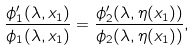Convert formula to latex. <formula><loc_0><loc_0><loc_500><loc_500>\frac { \phi _ { 1 } ^ { \prime } ( \lambda , x _ { 1 } ) } { \phi _ { 1 } ( \lambda , x _ { 1 } ) } = \frac { \phi _ { 2 } ^ { \prime } ( \lambda , \eta ( x _ { 1 } ) ) } { \phi _ { 2 } ( \lambda , \eta ( x _ { 1 } ) ) } ,</formula> 